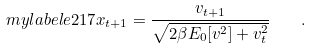<formula> <loc_0><loc_0><loc_500><loc_500>\ m y l a b e l { e 2 1 7 } x _ { t + 1 } = \frac { v _ { t + 1 } } { \sqrt { 2 \beta E _ { 0 } [ v ^ { 2 } ] + v _ { t } ^ { 2 } } } \quad .</formula> 